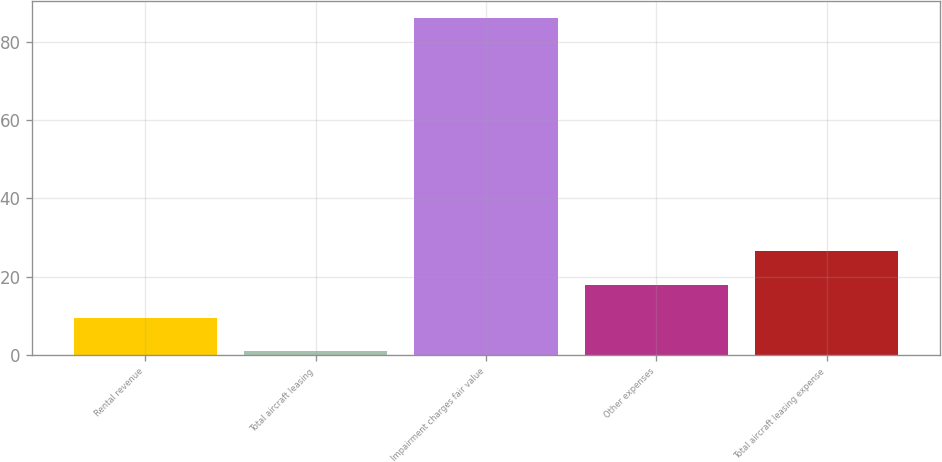<chart> <loc_0><loc_0><loc_500><loc_500><bar_chart><fcel>Rental revenue<fcel>Total aircraft leasing<fcel>Impairment charges fair value<fcel>Other expenses<fcel>Total aircraft leasing expense<nl><fcel>9.5<fcel>1<fcel>86<fcel>18<fcel>26.5<nl></chart> 